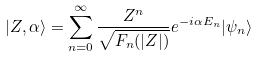Convert formula to latex. <formula><loc_0><loc_0><loc_500><loc_500>| Z , \alpha \rangle = \sum _ { n = 0 } ^ { \infty } \frac { Z ^ { n } } { \sqrt { F _ { n } ( | Z | ) } } e ^ { - i \alpha E _ { n } } | \psi _ { n } \rangle</formula> 